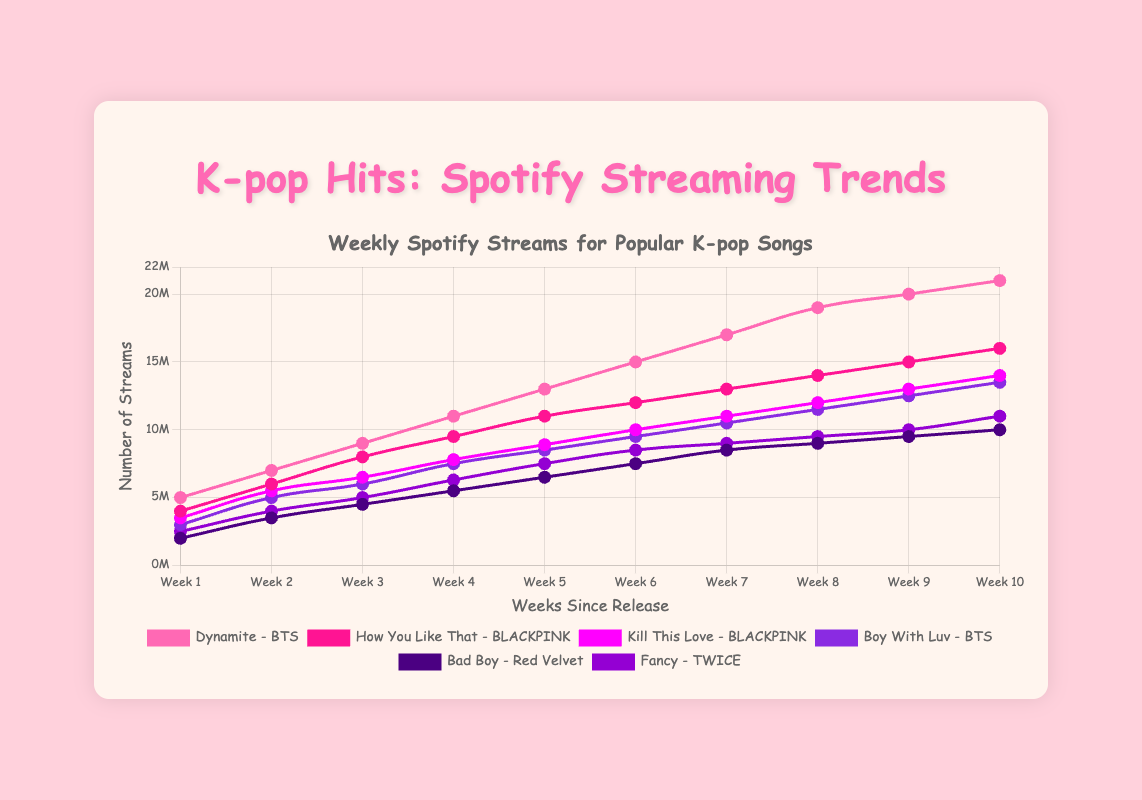What is the highest weekly stream count for "Dynamite" by BTS? Observing the "Dynamite" data points, the weekly streams increase to the highest value on Week 10, reaching 21,000,000 streams.
Answer: 21,000,000 Which song had the highest initial weekly streams? Comparing the first week's streams across all songs, "Dynamite" by BTS had the highest initial weekly streams with 5,000,000 streams.
Answer: Dynamite What is the total number of streams for "Boy With Luv" by BTS over 10 weeks? Summing up the streams: 3,000,000 + 5,000,000 + 6,000,000 + 7,500,000 + 8,500,000 + 9,500,000 + 10,500,000 + 11,500,000 + 12,500,000 + 13,500,000 = 88,000,000.
Answer: 88,000,000 Which song showed the steepest increase in streams from Week 1 to Week 2? Comparing change: "Dynamite": 2,000,000; "How You Like That": 2,000,000; "Kill This Love": 2,000,000; "Boy With Luv": 2,000,000; "Bad Boy": 1,500,000; "Fancy": 1,500,000. Multiple songs had equal increase, but no song showed a steeper increase than others.
Answer: Dynamite, How You Like That, Kill This Love, Boy With Luv Which artist has the most songs in the chart with the highest stream count? BTS has "Dynamite" with 21,000,000 and "Boy With Luv" with 13,500,000, while BLACKPINK has "How You Like That" with 16,000,000 and "Kill This Love" with 14,000,000, and other songs are less. Thus, BTS has more songs with higher counts.
Answer: BTS What is the average weekly stream count for "How You Like That" by BLACKPINK? Sum all weekly stream counts for "How You Like That": 4,000,000 + 6,000,000 + 8,000,000 + 9,500,000 + 11,000,000 + 12,000,000 + 13,000,000 + 14,000,000 + 15,000,000 + 16,000,000 = 109,500,000. Divide it by the number of weeks (10): 109,500,000 / 10 = 10,950,000.
Answer: 10,950,000 Which song has the slowest growth in streams over 10 weeks? Comparing overall growth (Streams in Week 10 - Streams in Week 1): "Dynamite": 21,000,000 - 5,000,000 = 16,000,000; "How You Like That": 16,000,000 - 4,000,000 = 12,000,000; "Kill This Love": 14,000,000 - 3,500,000 = 10,500,000; "Boy With Luv": 13,500,000 - 3,000,000 = 10,500,000; "Bad Boy": 10,000,000 - 2,000,000 = 8,000,000; "Fancy": 11,000,000 - 2,500,000 = 8,500,000. The song "Bad Boy" by Red Velvet has the slowest growth with 8,000,000 increase.
Answer: Bad Boy Which song reached 10,000,000 weekly streams the fastest? By looking at the weeks each song hits 10,000,000 streams: "Dynamite" in Week 4, "How You Like That" in Week 5, "Kill This Love" in Week 6, "Boy With Luv" in Week 6, "Bad Boy" in Week 10, "Fancy" in Week 9. "Dynamite" by BTS reached it the fastest in Week 4.
Answer: Dynamite What is the stream difference between "Dynamite" by BTS and "Kill This Love" by BLACKPINK in Week 10? In Week 10, "Dynamite" has 21,000,000 streams, and "Kill This Love" has 14,000,000 streams. The difference is 21,000,000 - 14,000,000 = 7,000,000.
Answer: 7,000,000 